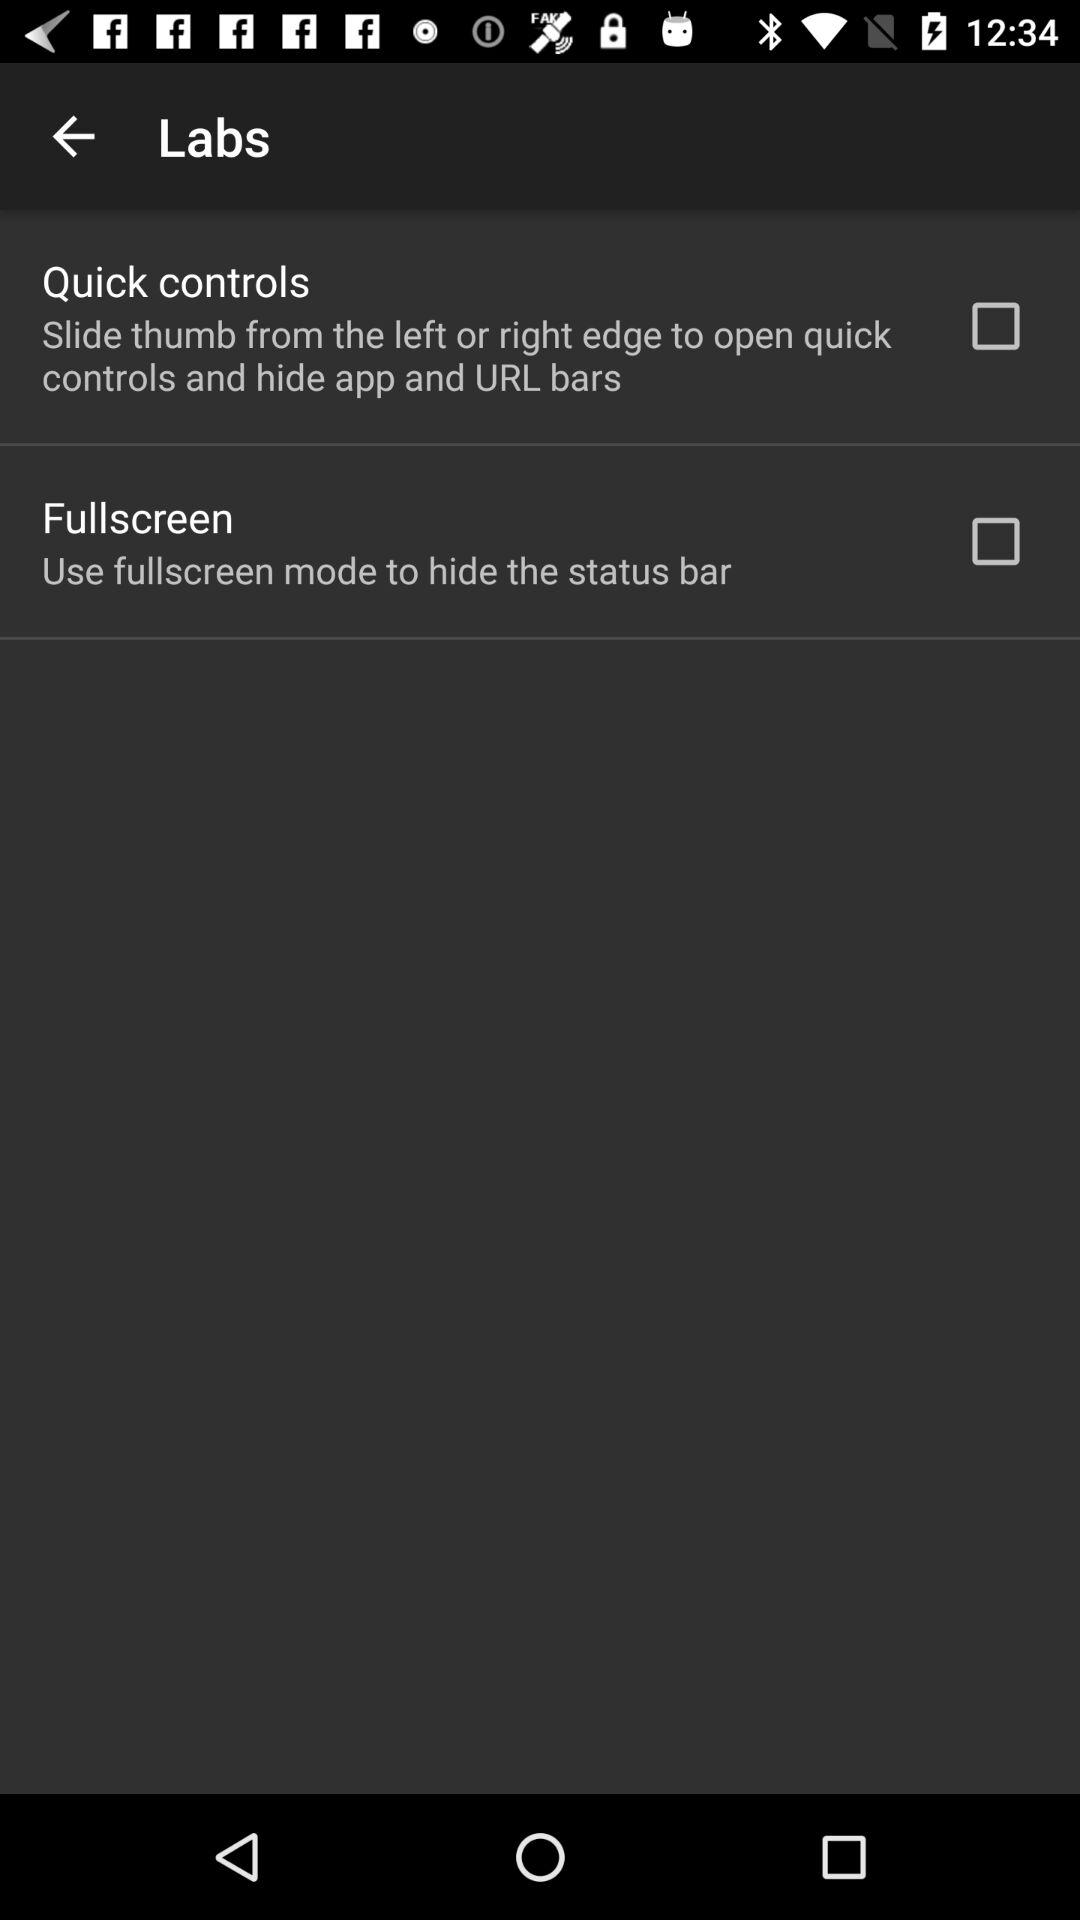Which tab is selected?
When the provided information is insufficient, respond with <no answer>. <no answer> 